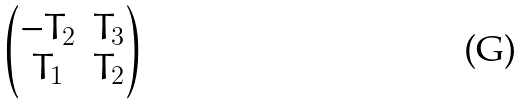<formula> <loc_0><loc_0><loc_500><loc_500>\begin{pmatrix} - T _ { 2 } & T _ { 3 } \\ T _ { 1 } & T _ { 2 } \end{pmatrix}</formula> 